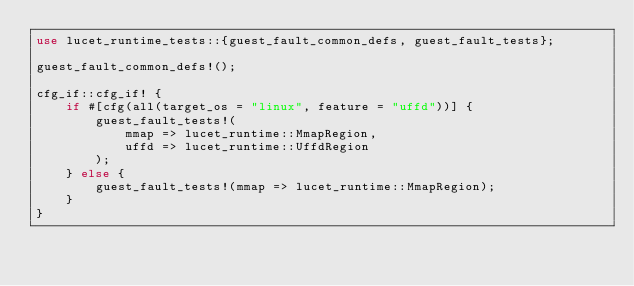<code> <loc_0><loc_0><loc_500><loc_500><_Rust_>use lucet_runtime_tests::{guest_fault_common_defs, guest_fault_tests};

guest_fault_common_defs!();

cfg_if::cfg_if! {
    if #[cfg(all(target_os = "linux", feature = "uffd"))] {
        guest_fault_tests!(
            mmap => lucet_runtime::MmapRegion,
            uffd => lucet_runtime::UffdRegion
        );
    } else {
        guest_fault_tests!(mmap => lucet_runtime::MmapRegion);
    }
}
</code> 